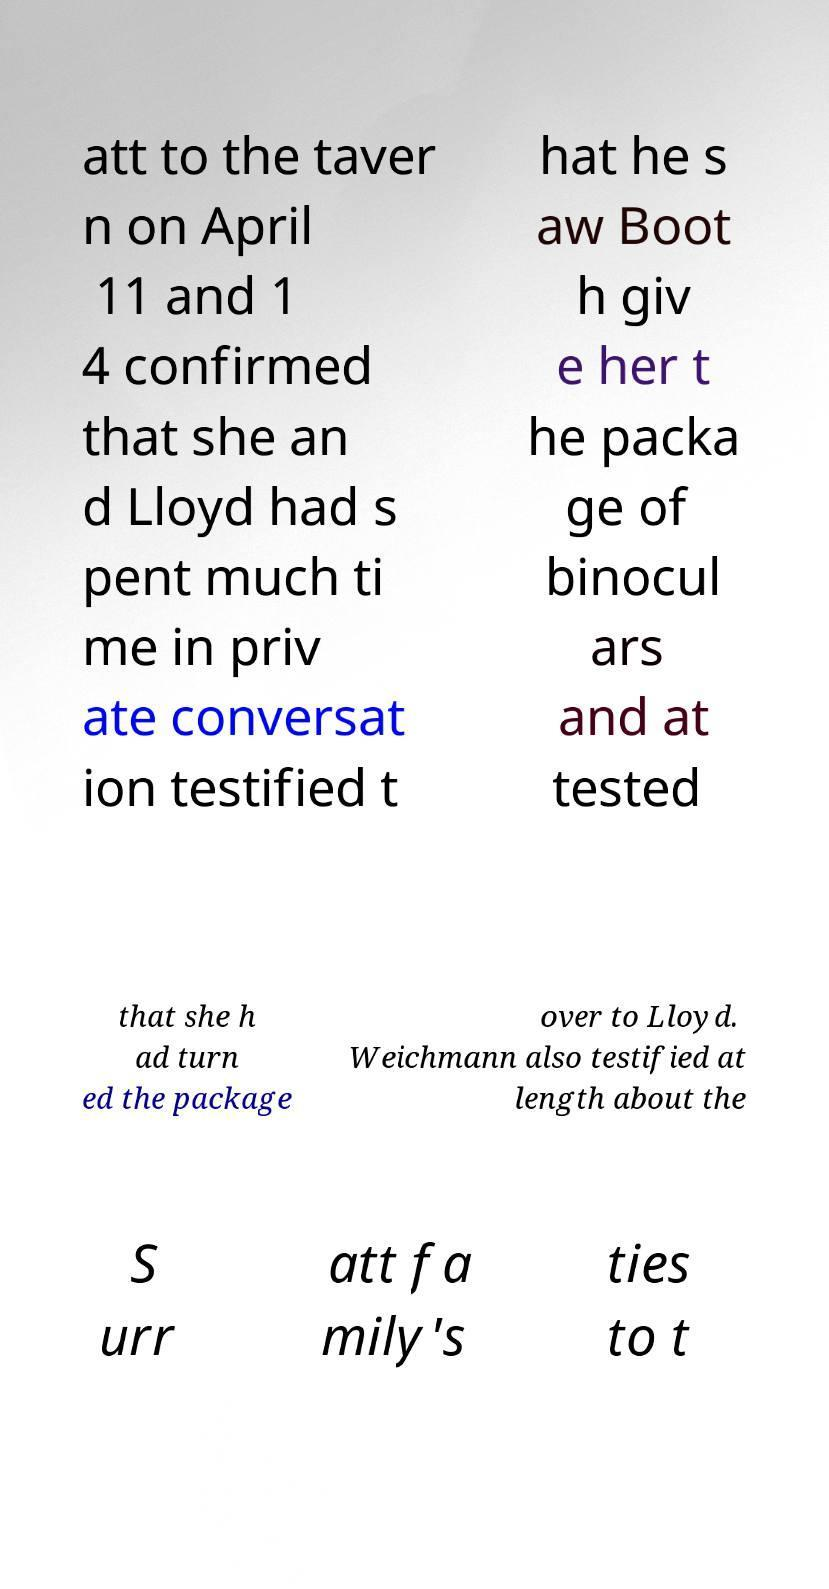Could you extract and type out the text from this image? att to the taver n on April 11 and 1 4 confirmed that she an d Lloyd had s pent much ti me in priv ate conversat ion testified t hat he s aw Boot h giv e her t he packa ge of binocul ars and at tested that she h ad turn ed the package over to Lloyd. Weichmann also testified at length about the S urr att fa mily's ties to t 